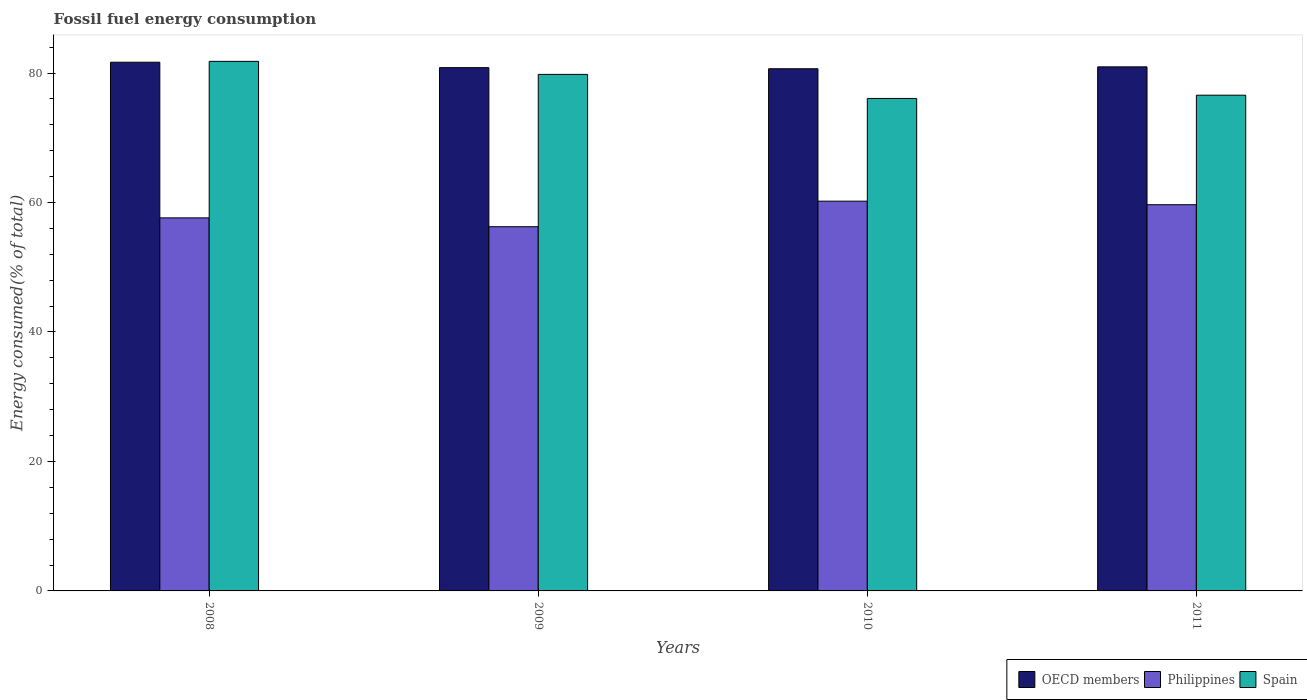How many different coloured bars are there?
Provide a succinct answer. 3. How many bars are there on the 1st tick from the right?
Give a very brief answer. 3. What is the label of the 2nd group of bars from the left?
Provide a succinct answer. 2009. In how many cases, is the number of bars for a given year not equal to the number of legend labels?
Your response must be concise. 0. What is the percentage of energy consumed in Spain in 2011?
Your answer should be very brief. 76.58. Across all years, what is the maximum percentage of energy consumed in Spain?
Your answer should be compact. 81.81. Across all years, what is the minimum percentage of energy consumed in OECD members?
Keep it short and to the point. 80.67. In which year was the percentage of energy consumed in Spain maximum?
Your answer should be compact. 2008. What is the total percentage of energy consumed in Philippines in the graph?
Offer a terse response. 233.77. What is the difference between the percentage of energy consumed in OECD members in 2009 and that in 2011?
Give a very brief answer. -0.12. What is the difference between the percentage of energy consumed in Spain in 2008 and the percentage of energy consumed in OECD members in 2010?
Keep it short and to the point. 1.14. What is the average percentage of energy consumed in Spain per year?
Provide a short and direct response. 78.57. In the year 2008, what is the difference between the percentage of energy consumed in OECD members and percentage of energy consumed in Philippines?
Provide a succinct answer. 24.04. In how many years, is the percentage of energy consumed in Spain greater than 56 %?
Keep it short and to the point. 4. What is the ratio of the percentage of energy consumed in Spain in 2008 to that in 2009?
Offer a very short reply. 1.03. Is the percentage of energy consumed in Philippines in 2008 less than that in 2009?
Your answer should be very brief. No. Is the difference between the percentage of energy consumed in OECD members in 2009 and 2010 greater than the difference between the percentage of energy consumed in Philippines in 2009 and 2010?
Make the answer very short. Yes. What is the difference between the highest and the second highest percentage of energy consumed in Philippines?
Your answer should be compact. 0.55. What is the difference between the highest and the lowest percentage of energy consumed in Philippines?
Keep it short and to the point. 3.95. In how many years, is the percentage of energy consumed in Spain greater than the average percentage of energy consumed in Spain taken over all years?
Your response must be concise. 2. Is the sum of the percentage of energy consumed in Philippines in 2008 and 2010 greater than the maximum percentage of energy consumed in OECD members across all years?
Your response must be concise. Yes. Is it the case that in every year, the sum of the percentage of energy consumed in Spain and percentage of energy consumed in Philippines is greater than the percentage of energy consumed in OECD members?
Keep it short and to the point. Yes. How many bars are there?
Your answer should be compact. 12. Are all the bars in the graph horizontal?
Your answer should be very brief. No. How many years are there in the graph?
Provide a short and direct response. 4. Are the values on the major ticks of Y-axis written in scientific E-notation?
Provide a short and direct response. No. Does the graph contain any zero values?
Give a very brief answer. No. Does the graph contain grids?
Your response must be concise. No. How many legend labels are there?
Give a very brief answer. 3. How are the legend labels stacked?
Your answer should be compact. Horizontal. What is the title of the graph?
Your answer should be compact. Fossil fuel energy consumption. Does "South Asia" appear as one of the legend labels in the graph?
Make the answer very short. No. What is the label or title of the Y-axis?
Your answer should be very brief. Energy consumed(% of total). What is the Energy consumed(% of total) in OECD members in 2008?
Provide a succinct answer. 81.67. What is the Energy consumed(% of total) of Philippines in 2008?
Your response must be concise. 57.63. What is the Energy consumed(% of total) of Spain in 2008?
Give a very brief answer. 81.81. What is the Energy consumed(% of total) in OECD members in 2009?
Offer a very short reply. 80.84. What is the Energy consumed(% of total) of Philippines in 2009?
Make the answer very short. 56.26. What is the Energy consumed(% of total) in Spain in 2009?
Your response must be concise. 79.79. What is the Energy consumed(% of total) in OECD members in 2010?
Your answer should be compact. 80.67. What is the Energy consumed(% of total) in Philippines in 2010?
Provide a succinct answer. 60.21. What is the Energy consumed(% of total) of Spain in 2010?
Your answer should be very brief. 76.08. What is the Energy consumed(% of total) of OECD members in 2011?
Provide a short and direct response. 80.96. What is the Energy consumed(% of total) of Philippines in 2011?
Provide a succinct answer. 59.66. What is the Energy consumed(% of total) in Spain in 2011?
Offer a terse response. 76.58. Across all years, what is the maximum Energy consumed(% of total) in OECD members?
Ensure brevity in your answer.  81.67. Across all years, what is the maximum Energy consumed(% of total) of Philippines?
Provide a succinct answer. 60.21. Across all years, what is the maximum Energy consumed(% of total) of Spain?
Ensure brevity in your answer.  81.81. Across all years, what is the minimum Energy consumed(% of total) of OECD members?
Give a very brief answer. 80.67. Across all years, what is the minimum Energy consumed(% of total) in Philippines?
Provide a short and direct response. 56.26. Across all years, what is the minimum Energy consumed(% of total) of Spain?
Offer a terse response. 76.08. What is the total Energy consumed(% of total) in OECD members in the graph?
Offer a terse response. 324.13. What is the total Energy consumed(% of total) of Philippines in the graph?
Your response must be concise. 233.77. What is the total Energy consumed(% of total) of Spain in the graph?
Your answer should be very brief. 314.26. What is the difference between the Energy consumed(% of total) of OECD members in 2008 and that in 2009?
Offer a terse response. 0.84. What is the difference between the Energy consumed(% of total) of Philippines in 2008 and that in 2009?
Keep it short and to the point. 1.37. What is the difference between the Energy consumed(% of total) of Spain in 2008 and that in 2009?
Provide a short and direct response. 2.02. What is the difference between the Energy consumed(% of total) of OECD members in 2008 and that in 2010?
Make the answer very short. 1.01. What is the difference between the Energy consumed(% of total) of Philippines in 2008 and that in 2010?
Offer a terse response. -2.58. What is the difference between the Energy consumed(% of total) of Spain in 2008 and that in 2010?
Make the answer very short. 5.73. What is the difference between the Energy consumed(% of total) of OECD members in 2008 and that in 2011?
Your response must be concise. 0.71. What is the difference between the Energy consumed(% of total) in Philippines in 2008 and that in 2011?
Keep it short and to the point. -2.03. What is the difference between the Energy consumed(% of total) in Spain in 2008 and that in 2011?
Offer a very short reply. 5.23. What is the difference between the Energy consumed(% of total) of OECD members in 2009 and that in 2010?
Keep it short and to the point. 0.17. What is the difference between the Energy consumed(% of total) in Philippines in 2009 and that in 2010?
Your response must be concise. -3.95. What is the difference between the Energy consumed(% of total) of Spain in 2009 and that in 2010?
Keep it short and to the point. 3.71. What is the difference between the Energy consumed(% of total) of OECD members in 2009 and that in 2011?
Provide a succinct answer. -0.12. What is the difference between the Energy consumed(% of total) in Philippines in 2009 and that in 2011?
Ensure brevity in your answer.  -3.4. What is the difference between the Energy consumed(% of total) of Spain in 2009 and that in 2011?
Your response must be concise. 3.21. What is the difference between the Energy consumed(% of total) in OECD members in 2010 and that in 2011?
Make the answer very short. -0.29. What is the difference between the Energy consumed(% of total) of Philippines in 2010 and that in 2011?
Your answer should be compact. 0.55. What is the difference between the Energy consumed(% of total) in Spain in 2010 and that in 2011?
Provide a succinct answer. -0.5. What is the difference between the Energy consumed(% of total) of OECD members in 2008 and the Energy consumed(% of total) of Philippines in 2009?
Keep it short and to the point. 25.41. What is the difference between the Energy consumed(% of total) in OECD members in 2008 and the Energy consumed(% of total) in Spain in 2009?
Your response must be concise. 1.88. What is the difference between the Energy consumed(% of total) of Philippines in 2008 and the Energy consumed(% of total) of Spain in 2009?
Your response must be concise. -22.16. What is the difference between the Energy consumed(% of total) in OECD members in 2008 and the Energy consumed(% of total) in Philippines in 2010?
Make the answer very short. 21.46. What is the difference between the Energy consumed(% of total) in OECD members in 2008 and the Energy consumed(% of total) in Spain in 2010?
Keep it short and to the point. 5.59. What is the difference between the Energy consumed(% of total) in Philippines in 2008 and the Energy consumed(% of total) in Spain in 2010?
Keep it short and to the point. -18.45. What is the difference between the Energy consumed(% of total) of OECD members in 2008 and the Energy consumed(% of total) of Philippines in 2011?
Your answer should be very brief. 22.01. What is the difference between the Energy consumed(% of total) in OECD members in 2008 and the Energy consumed(% of total) in Spain in 2011?
Keep it short and to the point. 5.09. What is the difference between the Energy consumed(% of total) in Philippines in 2008 and the Energy consumed(% of total) in Spain in 2011?
Your answer should be compact. -18.95. What is the difference between the Energy consumed(% of total) of OECD members in 2009 and the Energy consumed(% of total) of Philippines in 2010?
Make the answer very short. 20.63. What is the difference between the Energy consumed(% of total) in OECD members in 2009 and the Energy consumed(% of total) in Spain in 2010?
Provide a short and direct response. 4.76. What is the difference between the Energy consumed(% of total) of Philippines in 2009 and the Energy consumed(% of total) of Spain in 2010?
Your answer should be compact. -19.82. What is the difference between the Energy consumed(% of total) of OECD members in 2009 and the Energy consumed(% of total) of Philippines in 2011?
Make the answer very short. 21.17. What is the difference between the Energy consumed(% of total) in OECD members in 2009 and the Energy consumed(% of total) in Spain in 2011?
Provide a short and direct response. 4.26. What is the difference between the Energy consumed(% of total) of Philippines in 2009 and the Energy consumed(% of total) of Spain in 2011?
Give a very brief answer. -20.32. What is the difference between the Energy consumed(% of total) of OECD members in 2010 and the Energy consumed(% of total) of Philippines in 2011?
Provide a succinct answer. 21. What is the difference between the Energy consumed(% of total) of OECD members in 2010 and the Energy consumed(% of total) of Spain in 2011?
Offer a terse response. 4.09. What is the difference between the Energy consumed(% of total) in Philippines in 2010 and the Energy consumed(% of total) in Spain in 2011?
Keep it short and to the point. -16.37. What is the average Energy consumed(% of total) of OECD members per year?
Offer a very short reply. 81.03. What is the average Energy consumed(% of total) of Philippines per year?
Your answer should be very brief. 58.44. What is the average Energy consumed(% of total) in Spain per year?
Offer a very short reply. 78.56. In the year 2008, what is the difference between the Energy consumed(% of total) of OECD members and Energy consumed(% of total) of Philippines?
Keep it short and to the point. 24.04. In the year 2008, what is the difference between the Energy consumed(% of total) of OECD members and Energy consumed(% of total) of Spain?
Your answer should be compact. -0.14. In the year 2008, what is the difference between the Energy consumed(% of total) in Philippines and Energy consumed(% of total) in Spain?
Make the answer very short. -24.18. In the year 2009, what is the difference between the Energy consumed(% of total) of OECD members and Energy consumed(% of total) of Philippines?
Provide a short and direct response. 24.57. In the year 2009, what is the difference between the Energy consumed(% of total) in OECD members and Energy consumed(% of total) in Spain?
Make the answer very short. 1.04. In the year 2009, what is the difference between the Energy consumed(% of total) in Philippines and Energy consumed(% of total) in Spain?
Keep it short and to the point. -23.53. In the year 2010, what is the difference between the Energy consumed(% of total) in OECD members and Energy consumed(% of total) in Philippines?
Offer a terse response. 20.46. In the year 2010, what is the difference between the Energy consumed(% of total) in OECD members and Energy consumed(% of total) in Spain?
Your answer should be very brief. 4.59. In the year 2010, what is the difference between the Energy consumed(% of total) in Philippines and Energy consumed(% of total) in Spain?
Offer a very short reply. -15.87. In the year 2011, what is the difference between the Energy consumed(% of total) in OECD members and Energy consumed(% of total) in Philippines?
Your answer should be very brief. 21.3. In the year 2011, what is the difference between the Energy consumed(% of total) in OECD members and Energy consumed(% of total) in Spain?
Your answer should be very brief. 4.38. In the year 2011, what is the difference between the Energy consumed(% of total) in Philippines and Energy consumed(% of total) in Spain?
Offer a terse response. -16.92. What is the ratio of the Energy consumed(% of total) of OECD members in 2008 to that in 2009?
Make the answer very short. 1.01. What is the ratio of the Energy consumed(% of total) in Philippines in 2008 to that in 2009?
Keep it short and to the point. 1.02. What is the ratio of the Energy consumed(% of total) of Spain in 2008 to that in 2009?
Provide a short and direct response. 1.03. What is the ratio of the Energy consumed(% of total) of OECD members in 2008 to that in 2010?
Provide a short and direct response. 1.01. What is the ratio of the Energy consumed(% of total) in Philippines in 2008 to that in 2010?
Make the answer very short. 0.96. What is the ratio of the Energy consumed(% of total) in Spain in 2008 to that in 2010?
Offer a terse response. 1.08. What is the ratio of the Energy consumed(% of total) in OECD members in 2008 to that in 2011?
Make the answer very short. 1.01. What is the ratio of the Energy consumed(% of total) in Philippines in 2008 to that in 2011?
Ensure brevity in your answer.  0.97. What is the ratio of the Energy consumed(% of total) in Spain in 2008 to that in 2011?
Provide a succinct answer. 1.07. What is the ratio of the Energy consumed(% of total) of Philippines in 2009 to that in 2010?
Your answer should be very brief. 0.93. What is the ratio of the Energy consumed(% of total) of Spain in 2009 to that in 2010?
Your response must be concise. 1.05. What is the ratio of the Energy consumed(% of total) of OECD members in 2009 to that in 2011?
Your answer should be compact. 1. What is the ratio of the Energy consumed(% of total) of Philippines in 2009 to that in 2011?
Your response must be concise. 0.94. What is the ratio of the Energy consumed(% of total) of Spain in 2009 to that in 2011?
Provide a succinct answer. 1.04. What is the ratio of the Energy consumed(% of total) in OECD members in 2010 to that in 2011?
Provide a short and direct response. 1. What is the ratio of the Energy consumed(% of total) in Philippines in 2010 to that in 2011?
Your answer should be compact. 1.01. What is the difference between the highest and the second highest Energy consumed(% of total) of OECD members?
Keep it short and to the point. 0.71. What is the difference between the highest and the second highest Energy consumed(% of total) in Philippines?
Your response must be concise. 0.55. What is the difference between the highest and the second highest Energy consumed(% of total) of Spain?
Make the answer very short. 2.02. What is the difference between the highest and the lowest Energy consumed(% of total) of OECD members?
Keep it short and to the point. 1.01. What is the difference between the highest and the lowest Energy consumed(% of total) of Philippines?
Your response must be concise. 3.95. What is the difference between the highest and the lowest Energy consumed(% of total) of Spain?
Offer a very short reply. 5.73. 